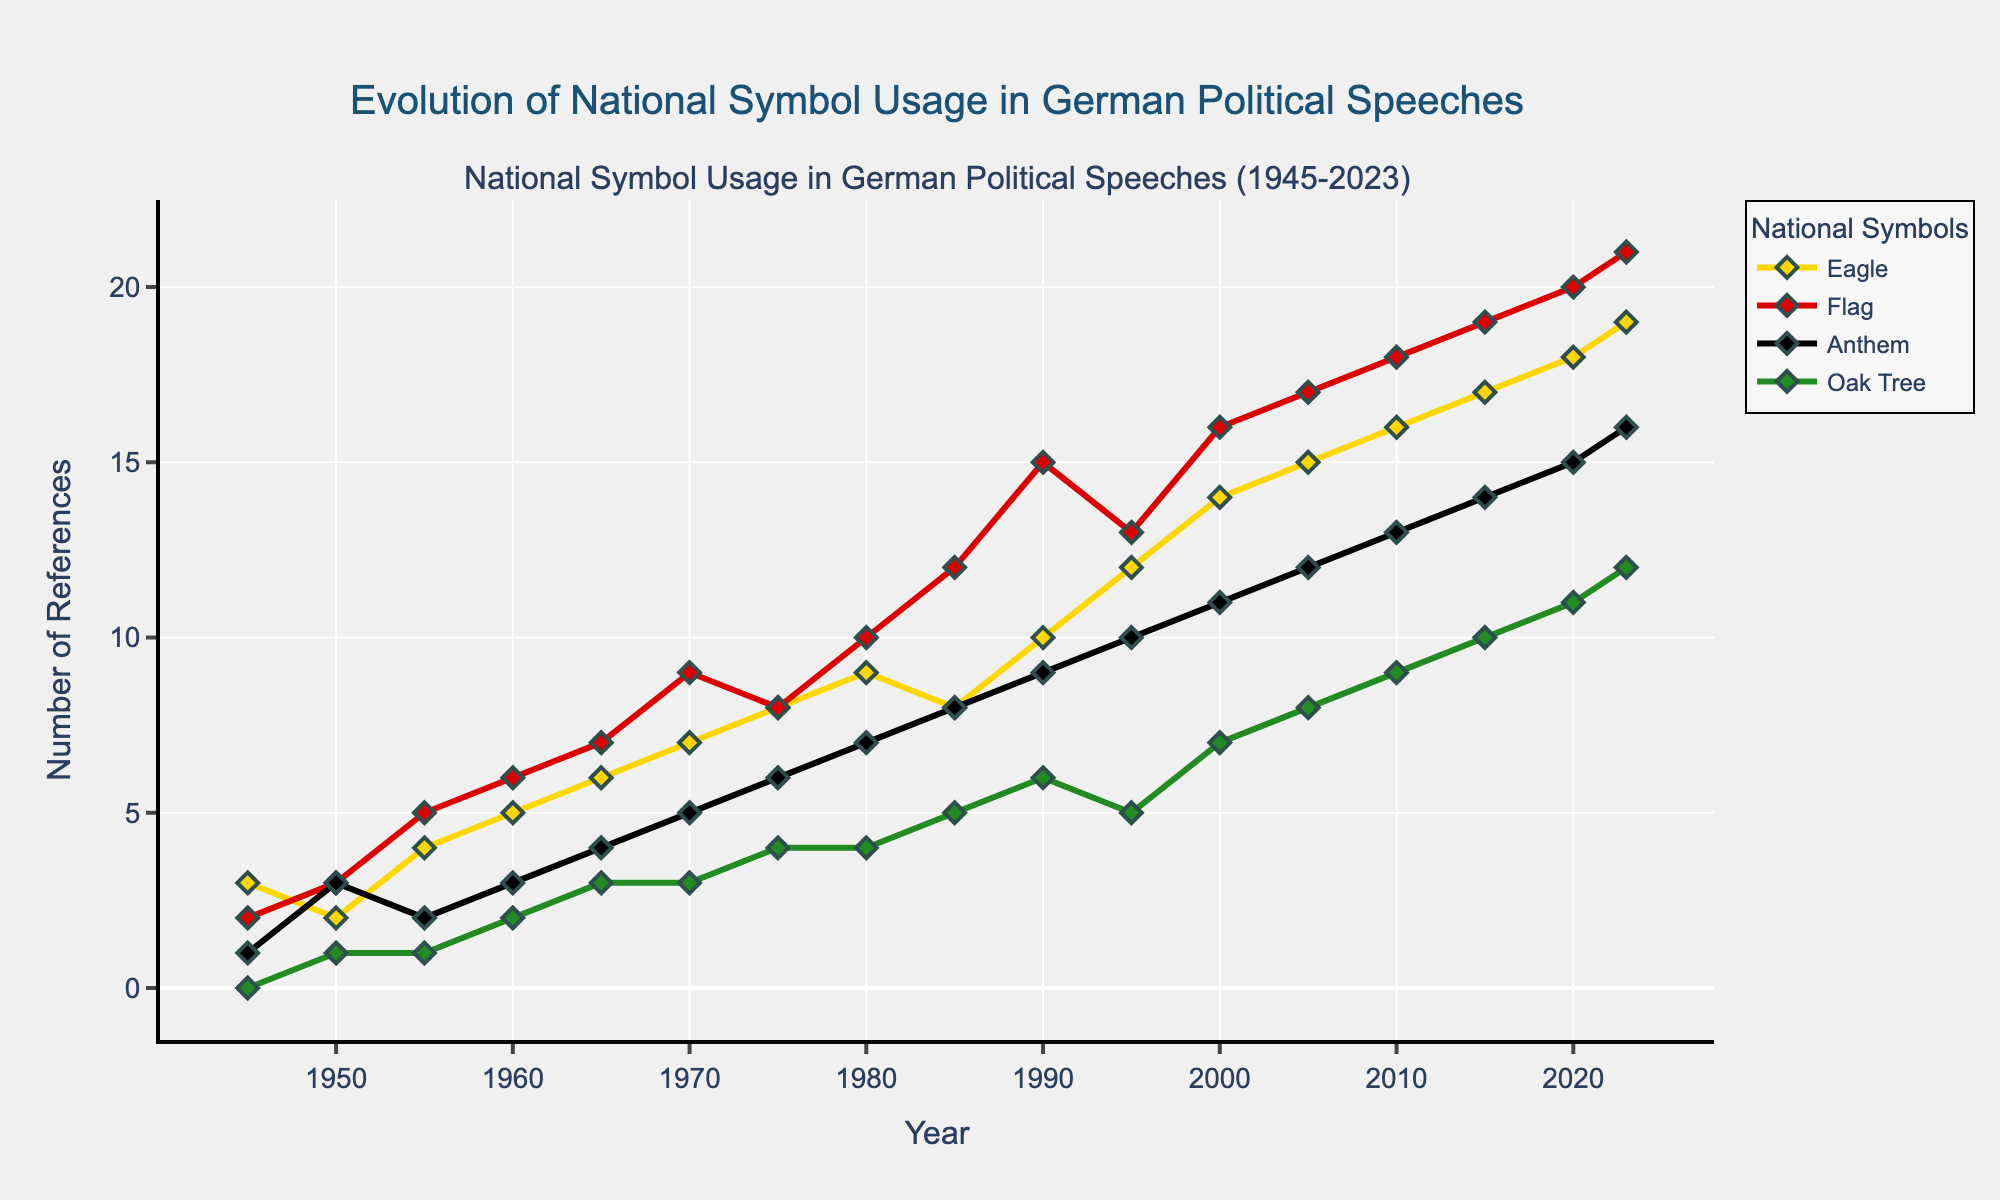What's the title of the plot? The title of the plot is located at the top of the figure, and it usually provides a summary of what the figure represents. In this case, it reads "Evolution of National Symbol Usage in German Political Speeches."
Answer: Evolution of National Symbol Usage in German Political Speeches What year had the highest number of speeches referenced? By examining the x-axis for the year and the y-axis for the number of references, one can see that the year 2023 has the tallest line on the plot representing the number of speeches.
Answer: 2023 Which national symbol saw the highest increase in references from 1945 to 2023? By comparing the initial and final points for each symbol, we can see the Eagle increased from 3 to 19, the Flag from 2 to 21, the Anthem from 1 to 16, and the Oak Tree from 0 to 12. The Flag had the highest increase.
Answer: Flag How many times was the national anthem referenced in 2005? Locate the point corresponding to the year 2005 on the x-axis and follow the line for the Anthem (black line) to find its value on the y-axis, which is 12.
Answer: 12 What is the average number of references to the Oak Tree between 1945 and 2023? Sum the number of references to the Oak Tree for each year and divide by the number of years. The total is 85 references over 16 data points, so 85/16 = 5.31.
Answer: 5.31 Which year saw an equal number of references to both the Eagle and the Flag? By finding where the lines for the Eagle and Flag intersect, we observe the lines cross at 1985, where both had 8 references.
Answer: 1985 Between 2000 and 2023, in how many years was the Eagle referenced more frequently than the Anthem? By looking at the interval from 2000 to 2023, we see that Eagle has more references than Anthem in each year of this interval (2000-2023) (14 > 11, 15 > 12, 16 > 13, 17 > 14, 18 > 15, 19 > 16). Six years in total.
Answer: 6 What national symbol had the smallest increase in references from 1990 to 2023? Total the differences in references for each symbol between 1990 and 2023. The smallest increase is found in the Oak Tree, as it went from 6 to 12, which is an increase of 6.
Answer: Oak Tree Which symbol was referenced the most in 2020? Look at the year 2020 and find the symbol with the highest point on the y-axis. The Flag, with 20 references, is the highest.
Answer: Flag What was the trend of references to the national flag from 1945 to 2023? The trend can be observed by following the line for the Flag (red line), showing a continuous increase from 2 to 21.
Answer: Continuous increase 